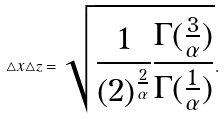<formula> <loc_0><loc_0><loc_500><loc_500>\triangle x \triangle z = \sqrt { \frac { 1 } { ( 2 ) ^ { \frac { 2 } { \alpha } } } \frac { \Gamma ( \frac { 3 } { \alpha } ) } { \Gamma ( \frac { 1 } { \alpha } ) } } .</formula> 